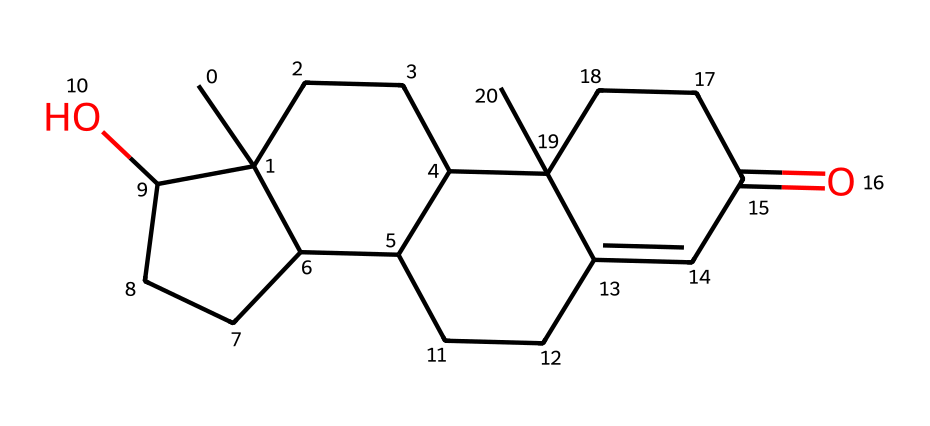What is the core structure of this steroid hormone? The core structure can be identified by the fusion of four cycloalkane rings, which is characteristic of steroid hormones. Analyzing the SMILES indicates that it has multiple fused rings, typical of steroids.
Answer: four cycloalkane rings How many oxygen atoms are present in this molecule? By reviewing the SMILES string, we can identify the presence of 'O' which indicates oxygen. The string shows a single 'O', suggesting that there is one oxygen atom in the molecular structure.
Answer: one What type of lipid does this structure represent? The distinct fused ring structure and the presence of a hydroxyl group (-O) indicate that this molecule is a steroid. This is a specific classification within the lipid category, denoting its unique features and functions in the body.
Answer: steroid How many carbon atoms are in this molecule? By counting the 'C' symbols in the SMILES representation, we can determine the total number of carbon atoms. The counting reveals that there are 21 carbon atoms throughout the entire structure.
Answer: twenty-one What is the functional group present in this steroid hormone? The hydroxyl group (-OH) in the structure suggests that this molecule possesses alcohol functionality, inherent in many steroid hormones which contribute to their solubility and biological activity.
Answer: hydroxyl group 